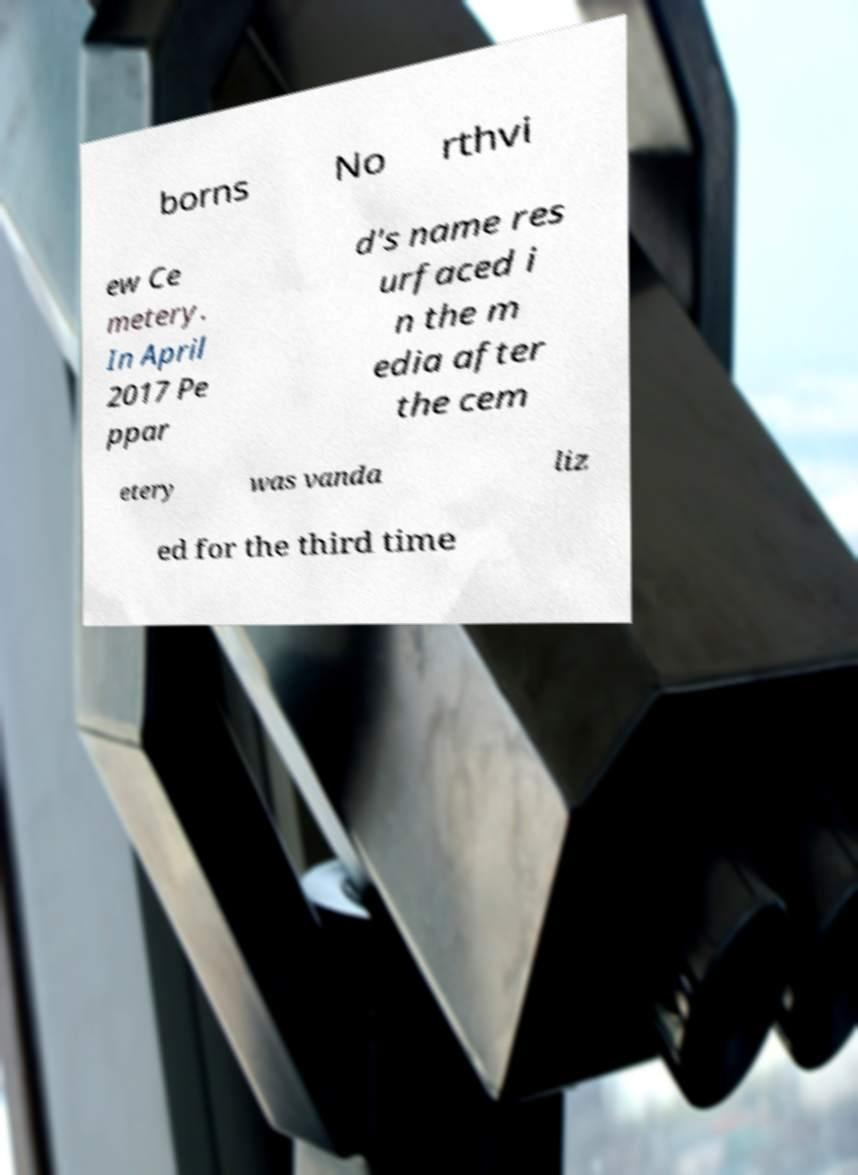Can you read and provide the text displayed in the image?This photo seems to have some interesting text. Can you extract and type it out for me? borns No rthvi ew Ce metery. In April 2017 Pe ppar d's name res urfaced i n the m edia after the cem etery was vanda liz ed for the third time 